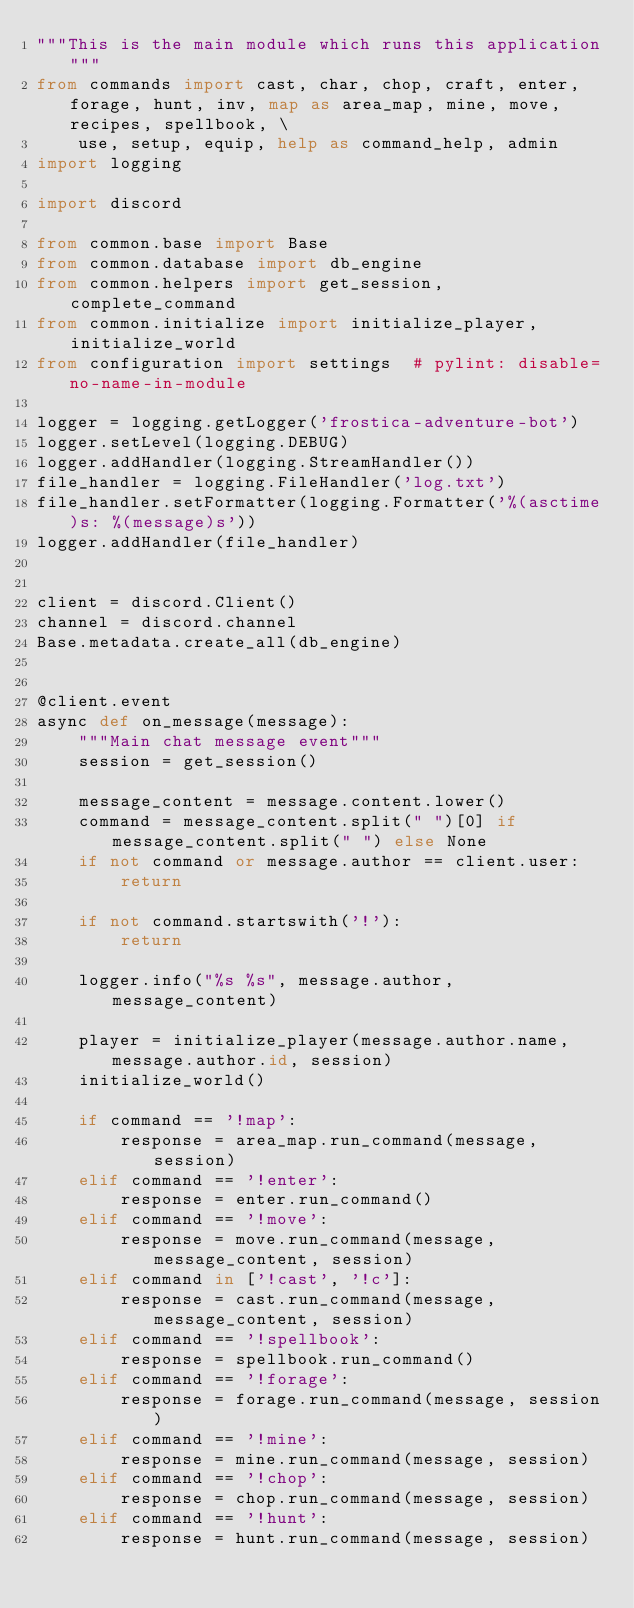<code> <loc_0><loc_0><loc_500><loc_500><_Python_>"""This is the main module which runs this application"""
from commands import cast, char, chop, craft, enter, forage, hunt, inv, map as area_map, mine, move, recipes, spellbook, \
    use, setup, equip, help as command_help, admin
import logging

import discord

from common.base import Base
from common.database import db_engine
from common.helpers import get_session, complete_command
from common.initialize import initialize_player, initialize_world
from configuration import settings  # pylint: disable=no-name-in-module

logger = logging.getLogger('frostica-adventure-bot')
logger.setLevel(logging.DEBUG)
logger.addHandler(logging.StreamHandler())
file_handler = logging.FileHandler('log.txt')
file_handler.setFormatter(logging.Formatter('%(asctime)s: %(message)s'))
logger.addHandler(file_handler)


client = discord.Client()
channel = discord.channel
Base.metadata.create_all(db_engine)


@client.event
async def on_message(message):
    """Main chat message event"""
    session = get_session()

    message_content = message.content.lower()
    command = message_content.split(" ")[0] if message_content.split(" ") else None
    if not command or message.author == client.user:
        return

    if not command.startswith('!'):
        return

    logger.info("%s %s", message.author, message_content)

    player = initialize_player(message.author.name, message.author.id, session)
    initialize_world()

    if command == '!map':
        response = area_map.run_command(message, session)
    elif command == '!enter':
        response = enter.run_command()
    elif command == '!move':
        response = move.run_command(message, message_content, session)
    elif command in ['!cast', '!c']:
        response = cast.run_command(message, message_content, session)
    elif command == '!spellbook':
        response = spellbook.run_command()
    elif command == '!forage':
        response = forage.run_command(message, session)
    elif command == '!mine':
        response = mine.run_command(message, session)
    elif command == '!chop':
        response = chop.run_command(message, session)
    elif command == '!hunt':
        response = hunt.run_command(message, session)</code> 